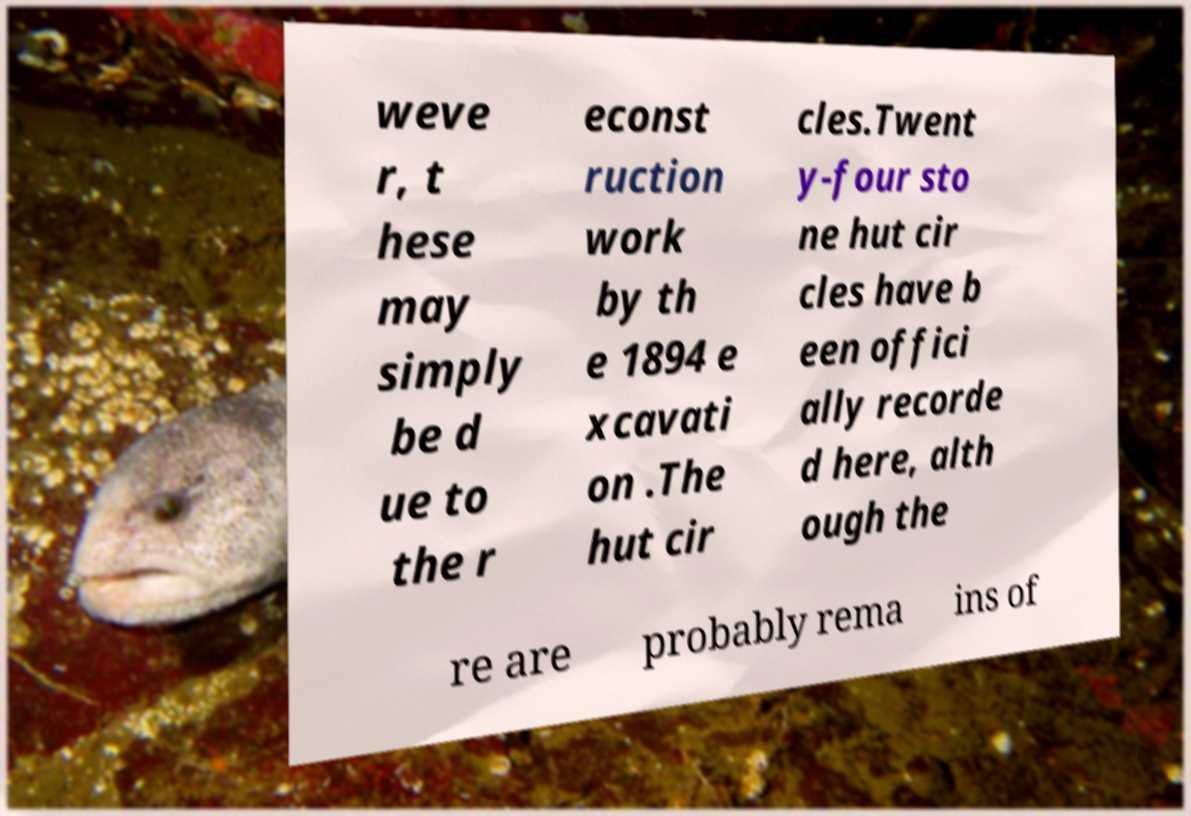Can you accurately transcribe the text from the provided image for me? weve r, t hese may simply be d ue to the r econst ruction work by th e 1894 e xcavati on .The hut cir cles.Twent y-four sto ne hut cir cles have b een offici ally recorde d here, alth ough the re are probably rema ins of 